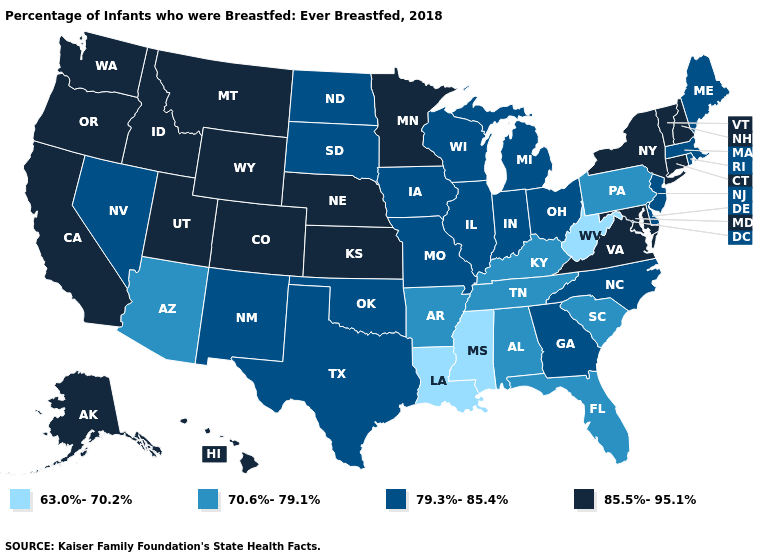Name the states that have a value in the range 63.0%-70.2%?
Concise answer only. Louisiana, Mississippi, West Virginia. Which states have the lowest value in the Northeast?
Answer briefly. Pennsylvania. Which states have the highest value in the USA?
Keep it brief. Alaska, California, Colorado, Connecticut, Hawaii, Idaho, Kansas, Maryland, Minnesota, Montana, Nebraska, New Hampshire, New York, Oregon, Utah, Vermont, Virginia, Washington, Wyoming. What is the value of New Jersey?
Keep it brief. 79.3%-85.4%. Does North Carolina have the lowest value in the USA?
Be succinct. No. Which states have the lowest value in the USA?
Quick response, please. Louisiana, Mississippi, West Virginia. Does Ohio have the highest value in the USA?
Quick response, please. No. Name the states that have a value in the range 85.5%-95.1%?
Short answer required. Alaska, California, Colorado, Connecticut, Hawaii, Idaho, Kansas, Maryland, Minnesota, Montana, Nebraska, New Hampshire, New York, Oregon, Utah, Vermont, Virginia, Washington, Wyoming. Name the states that have a value in the range 85.5%-95.1%?
Be succinct. Alaska, California, Colorado, Connecticut, Hawaii, Idaho, Kansas, Maryland, Minnesota, Montana, Nebraska, New Hampshire, New York, Oregon, Utah, Vermont, Virginia, Washington, Wyoming. Does Georgia have the highest value in the South?
Short answer required. No. Does Iowa have the same value as North Carolina?
Answer briefly. Yes. Name the states that have a value in the range 63.0%-70.2%?
Write a very short answer. Louisiana, Mississippi, West Virginia. What is the lowest value in the USA?
Concise answer only. 63.0%-70.2%. Among the states that border Nebraska , which have the highest value?
Be succinct. Colorado, Kansas, Wyoming. What is the highest value in states that border Kansas?
Write a very short answer. 85.5%-95.1%. 